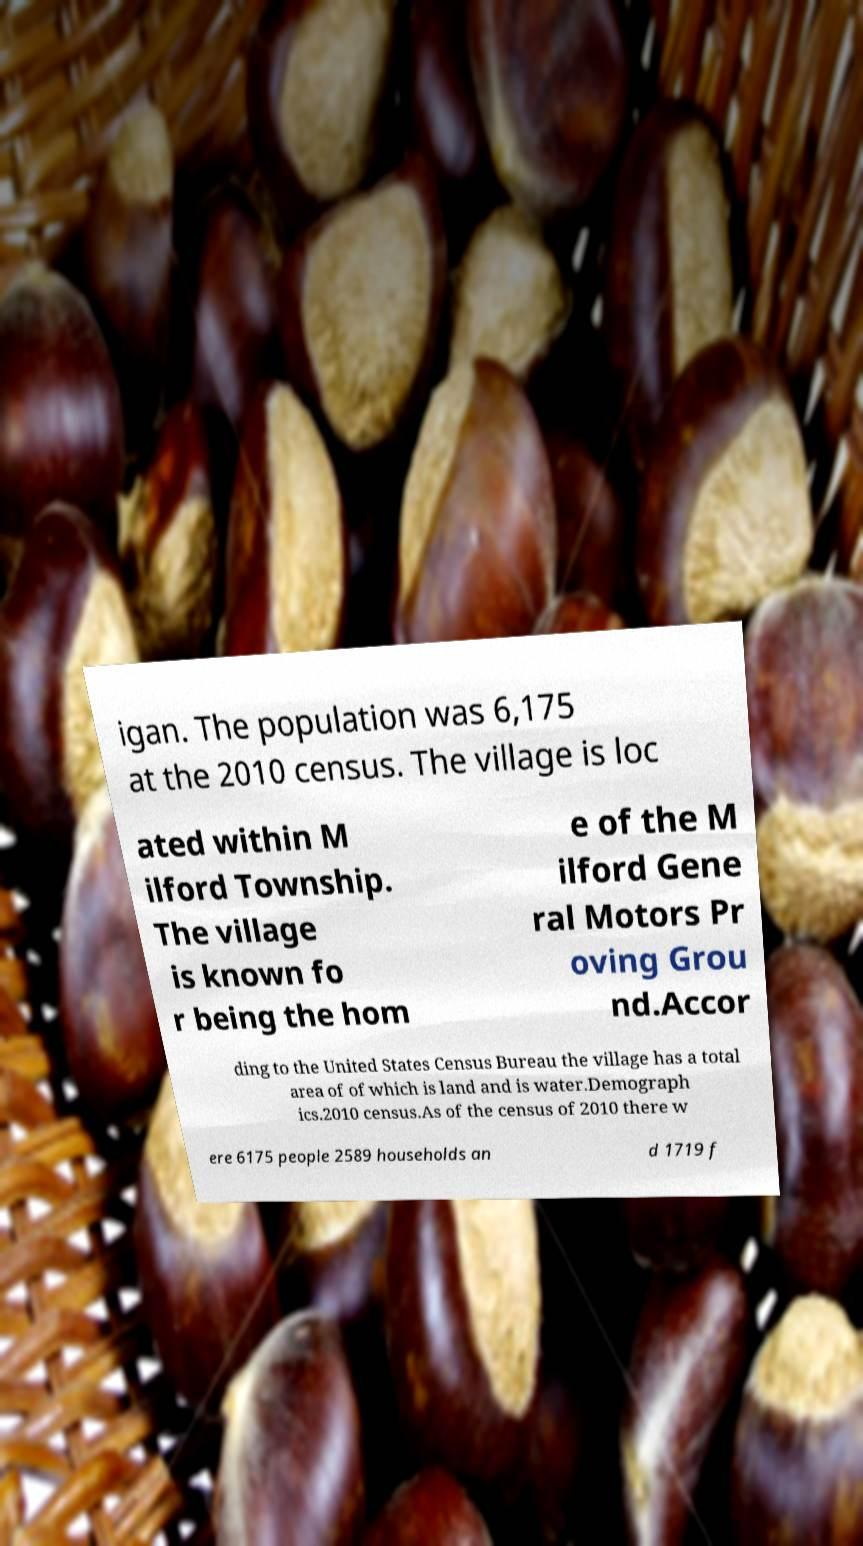Could you extract and type out the text from this image? igan. The population was 6,175 at the 2010 census. The village is loc ated within M ilford Township. The village is known fo r being the hom e of the M ilford Gene ral Motors Pr oving Grou nd.Accor ding to the United States Census Bureau the village has a total area of of which is land and is water.Demograph ics.2010 census.As of the census of 2010 there w ere 6175 people 2589 households an d 1719 f 